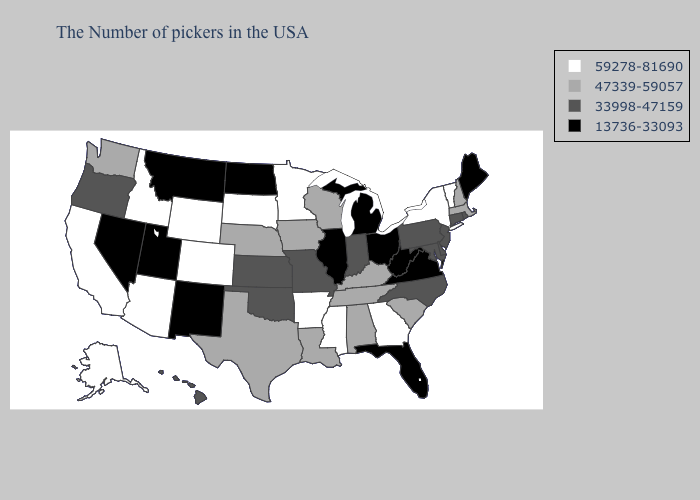Name the states that have a value in the range 47339-59057?
Give a very brief answer. Massachusetts, New Hampshire, South Carolina, Kentucky, Alabama, Tennessee, Wisconsin, Louisiana, Iowa, Nebraska, Texas, Washington. What is the lowest value in the West?
Give a very brief answer. 13736-33093. Does Minnesota have a lower value than West Virginia?
Answer briefly. No. Does Ohio have the lowest value in the MidWest?
Keep it brief. Yes. Name the states that have a value in the range 47339-59057?
Short answer required. Massachusetts, New Hampshire, South Carolina, Kentucky, Alabama, Tennessee, Wisconsin, Louisiana, Iowa, Nebraska, Texas, Washington. What is the value of New Hampshire?
Concise answer only. 47339-59057. What is the lowest value in states that border Illinois?
Keep it brief. 33998-47159. Name the states that have a value in the range 59278-81690?
Give a very brief answer. Vermont, New York, Georgia, Mississippi, Arkansas, Minnesota, South Dakota, Wyoming, Colorado, Arizona, Idaho, California, Alaska. What is the lowest value in the USA?
Keep it brief. 13736-33093. Name the states that have a value in the range 33998-47159?
Short answer required. Rhode Island, Connecticut, New Jersey, Delaware, Maryland, Pennsylvania, North Carolina, Indiana, Missouri, Kansas, Oklahoma, Oregon, Hawaii. What is the value of South Carolina?
Quick response, please. 47339-59057. What is the value of West Virginia?
Short answer required. 13736-33093. How many symbols are there in the legend?
Short answer required. 4. Among the states that border Virginia , does Kentucky have the highest value?
Write a very short answer. Yes. Does Virginia have the lowest value in the USA?
Give a very brief answer. Yes. 